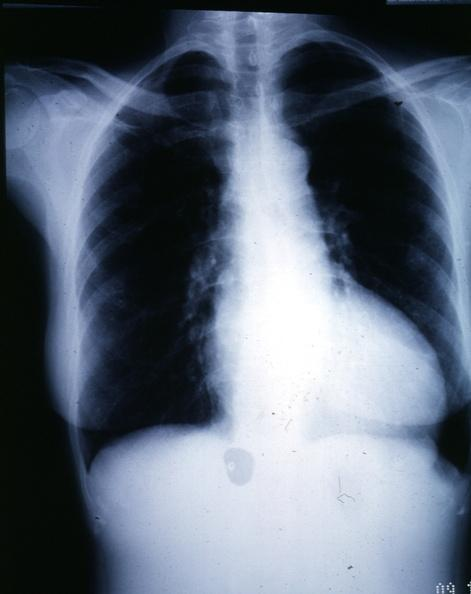s left ventricle hypertrophy present?
Answer the question using a single word or phrase. Yes 